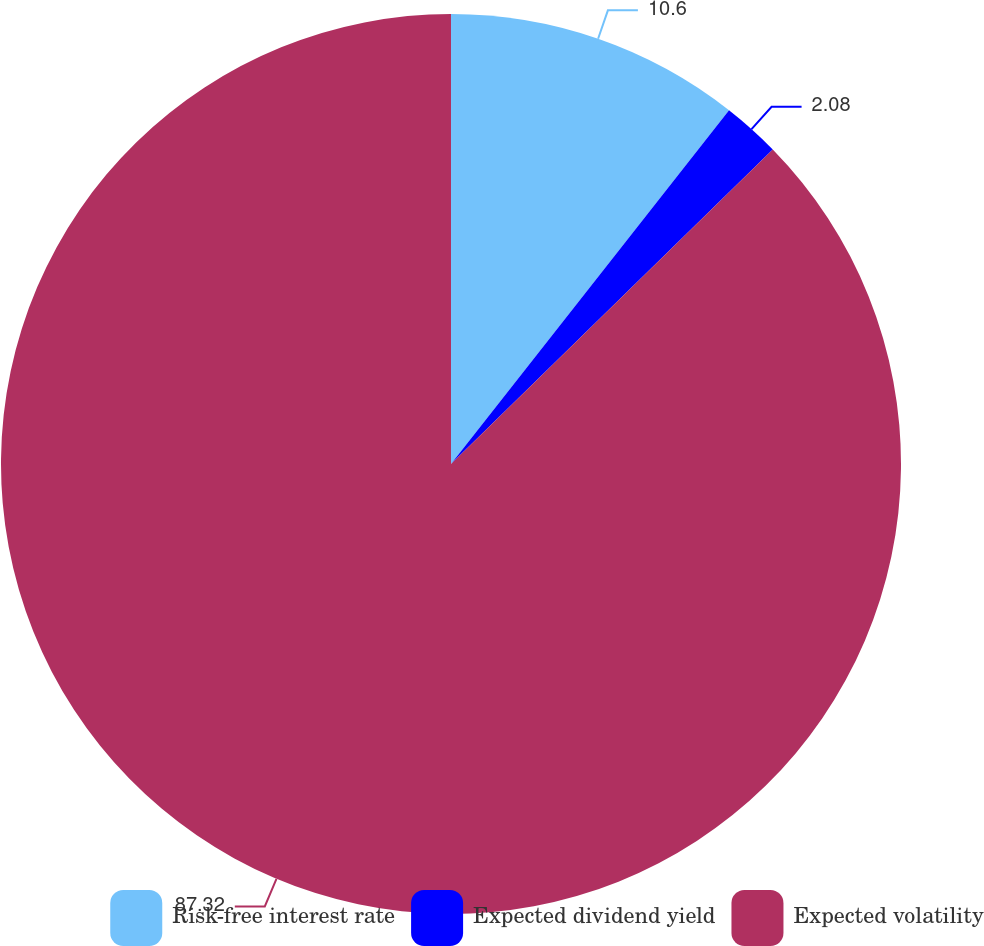Convert chart. <chart><loc_0><loc_0><loc_500><loc_500><pie_chart><fcel>Risk-free interest rate<fcel>Expected dividend yield<fcel>Expected volatility<nl><fcel>10.6%<fcel>2.08%<fcel>87.32%<nl></chart> 